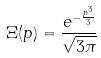<formula> <loc_0><loc_0><loc_500><loc_500>\Xi ( p ) = \frac { e ^ { - \frac { p ^ { 3 } } { 3 } } } { \sqrt { 3 \pi } }</formula> 